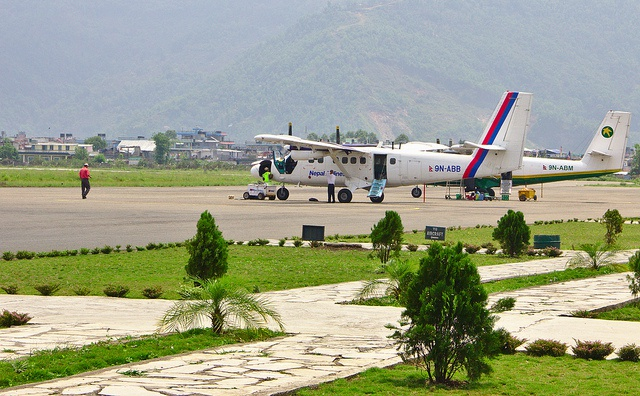Describe the objects in this image and their specific colors. I can see airplane in darkgray, lightgray, black, and gray tones, people in darkgray, black, brown, maroon, and salmon tones, people in darkgray, black, and maroon tones, and people in darkgray, lime, black, and olive tones in this image. 